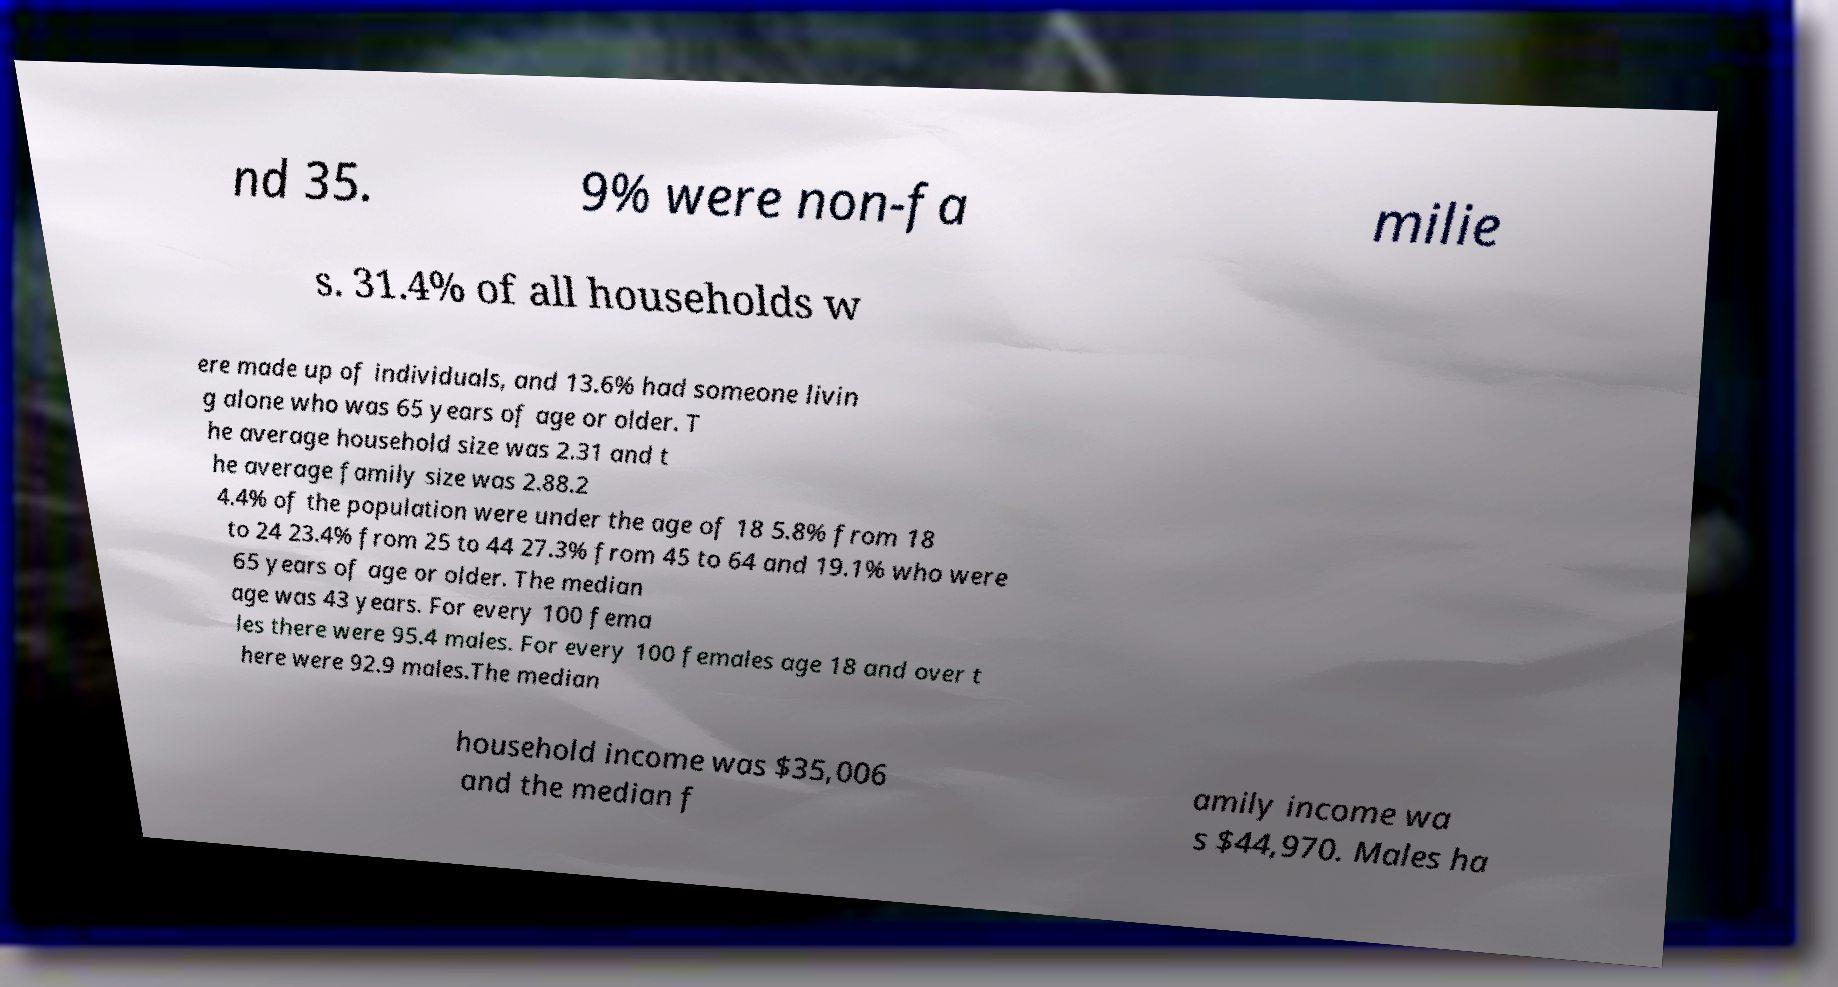For documentation purposes, I need the text within this image transcribed. Could you provide that? nd 35. 9% were non-fa milie s. 31.4% of all households w ere made up of individuals, and 13.6% had someone livin g alone who was 65 years of age or older. T he average household size was 2.31 and t he average family size was 2.88.2 4.4% of the population were under the age of 18 5.8% from 18 to 24 23.4% from 25 to 44 27.3% from 45 to 64 and 19.1% who were 65 years of age or older. The median age was 43 years. For every 100 fema les there were 95.4 males. For every 100 females age 18 and over t here were 92.9 males.The median household income was $35,006 and the median f amily income wa s $44,970. Males ha 